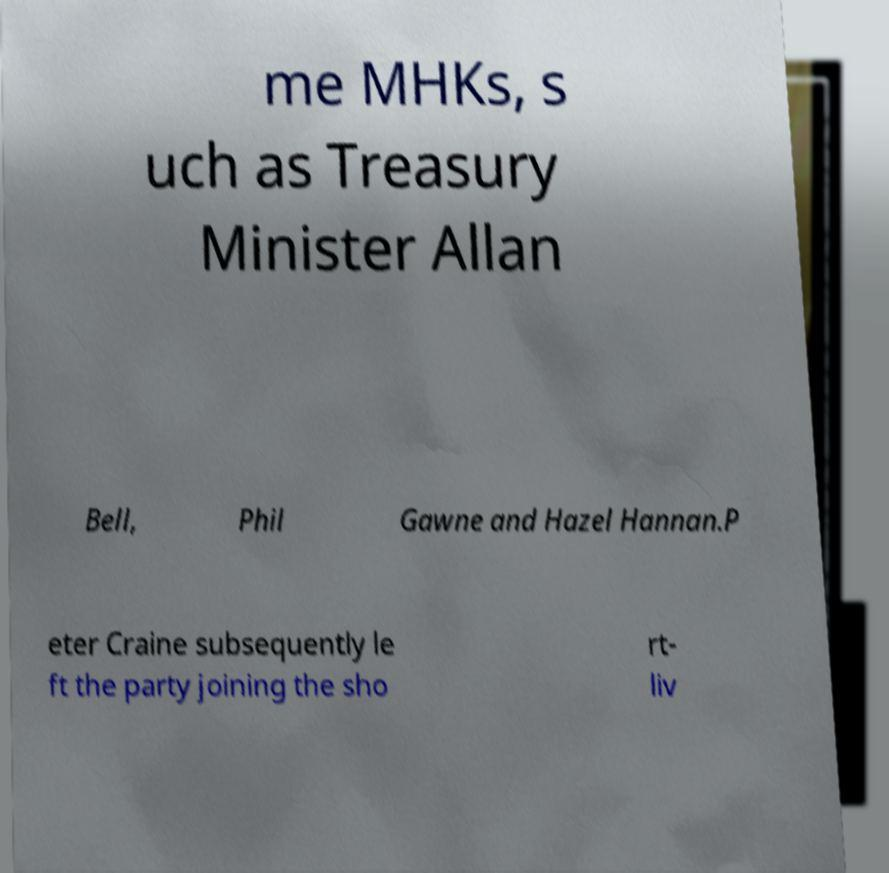There's text embedded in this image that I need extracted. Can you transcribe it verbatim? me MHKs, s uch as Treasury Minister Allan Bell, Phil Gawne and Hazel Hannan.P eter Craine subsequently le ft the party joining the sho rt- liv 